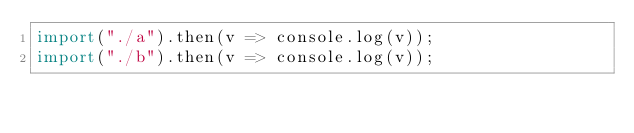<code> <loc_0><loc_0><loc_500><loc_500><_JavaScript_>import("./a").then(v => console.log(v));
import("./b").then(v => console.log(v));
</code> 